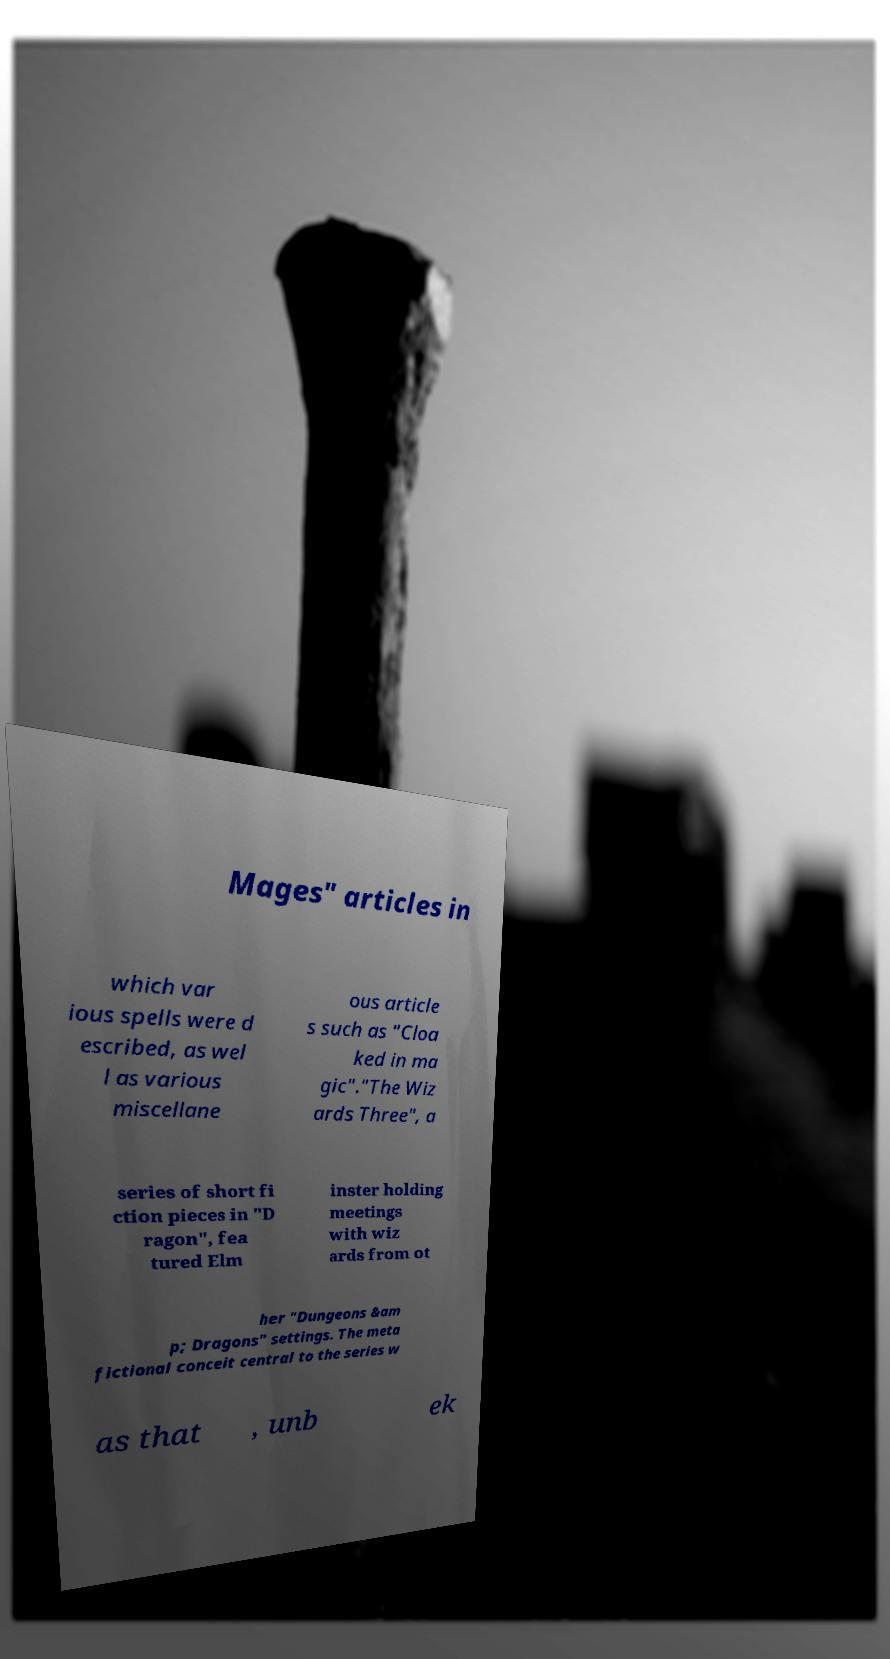Please read and relay the text visible in this image. What does it say? Mages" articles in which var ious spells were d escribed, as wel l as various miscellane ous article s such as "Cloa ked in ma gic"."The Wiz ards Three", a series of short fi ction pieces in "D ragon", fea tured Elm inster holding meetings with wiz ards from ot her "Dungeons &am p; Dragons" settings. The meta fictional conceit central to the series w as that , unb ek 